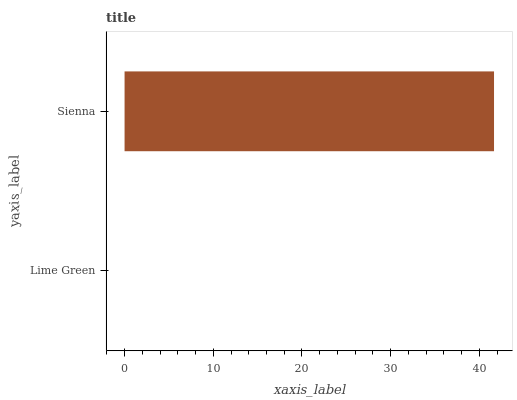Is Lime Green the minimum?
Answer yes or no. Yes. Is Sienna the maximum?
Answer yes or no. Yes. Is Sienna the minimum?
Answer yes or no. No. Is Sienna greater than Lime Green?
Answer yes or no. Yes. Is Lime Green less than Sienna?
Answer yes or no. Yes. Is Lime Green greater than Sienna?
Answer yes or no. No. Is Sienna less than Lime Green?
Answer yes or no. No. Is Sienna the high median?
Answer yes or no. Yes. Is Lime Green the low median?
Answer yes or no. Yes. Is Lime Green the high median?
Answer yes or no. No. Is Sienna the low median?
Answer yes or no. No. 